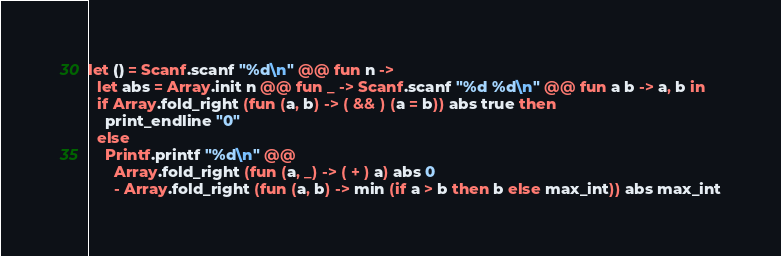<code> <loc_0><loc_0><loc_500><loc_500><_OCaml_>let () = Scanf.scanf "%d\n" @@ fun n ->
  let abs = Array.init n @@ fun _ -> Scanf.scanf "%d %d\n" @@ fun a b -> a, b in
  if Array.fold_right (fun (a, b) -> ( && ) (a = b)) abs true then
    print_endline "0"
  else
    Printf.printf "%d\n" @@
      Array.fold_right (fun (a, _) -> ( + ) a) abs 0
      - Array.fold_right (fun (a, b) -> min (if a > b then b else max_int)) abs max_int
</code> 